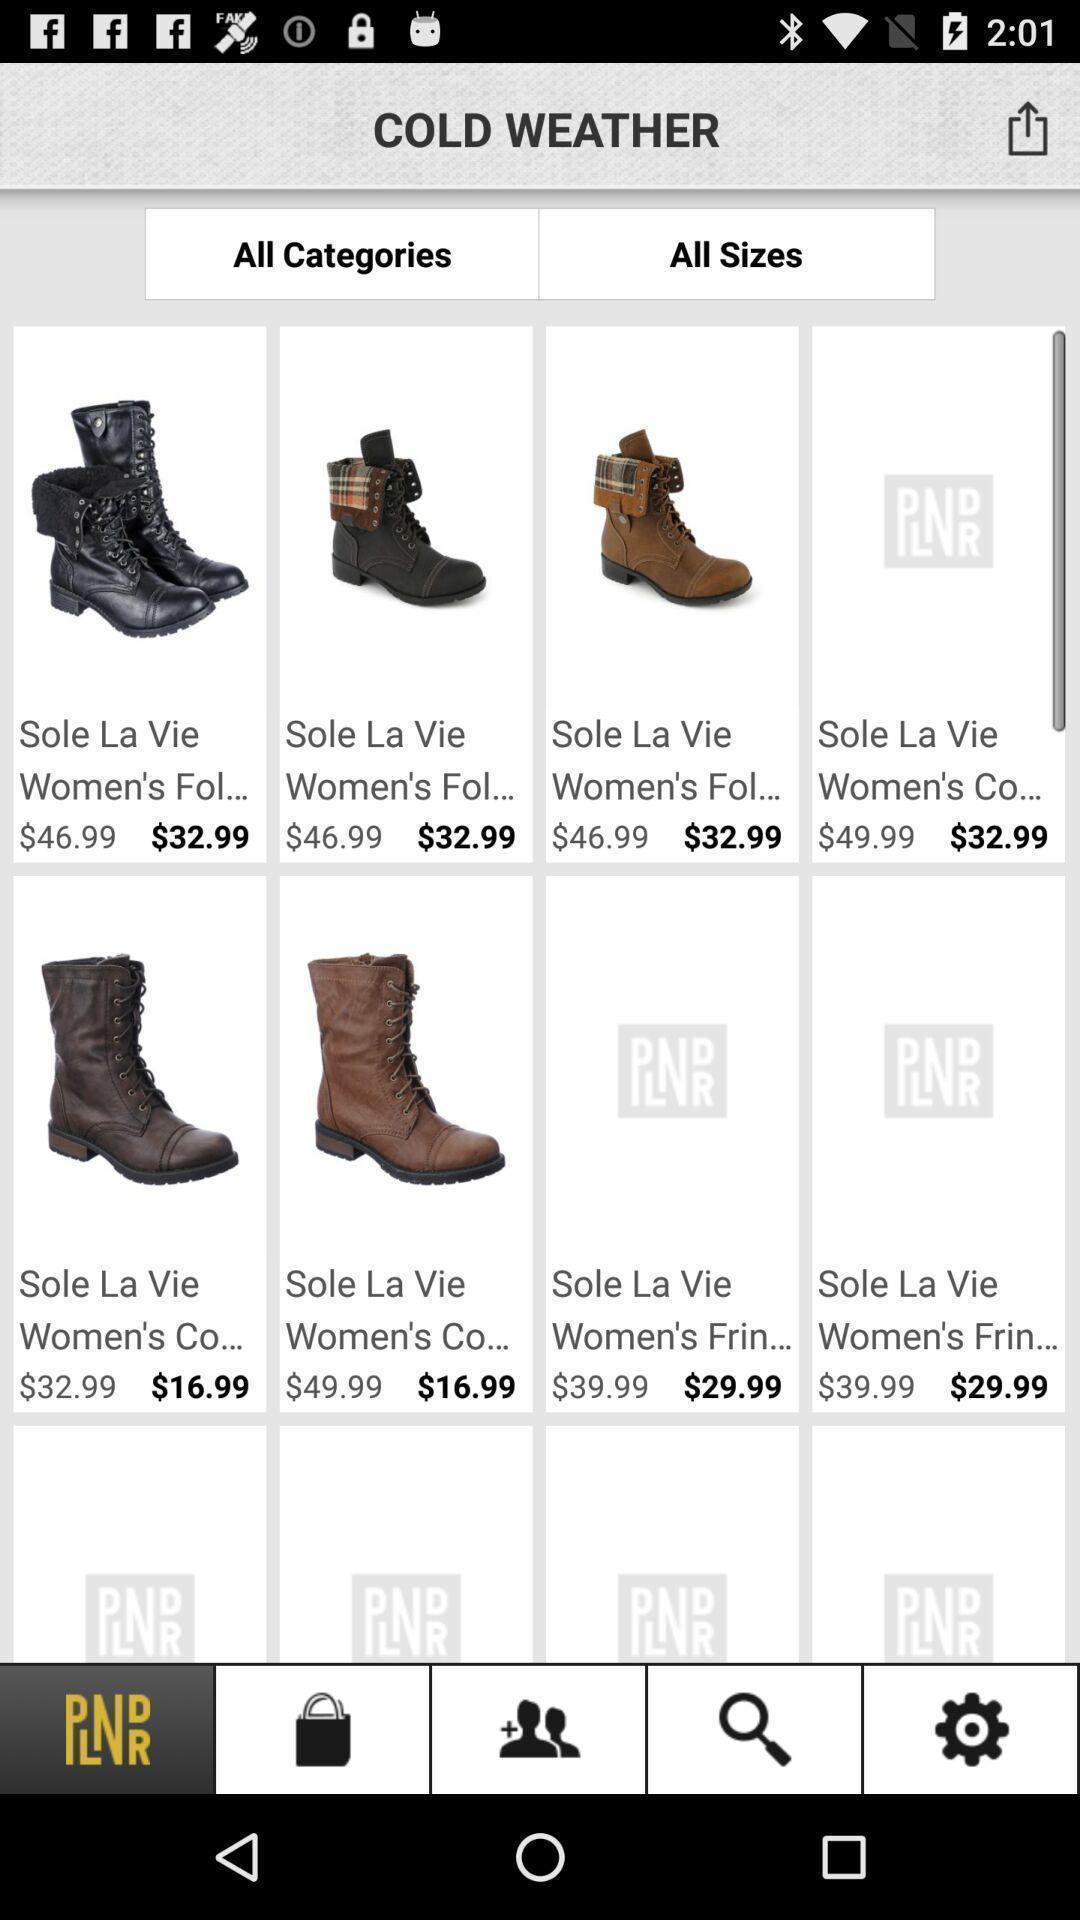Provide a textual representation of this image. Screen shows multiple products in a shopping application. 